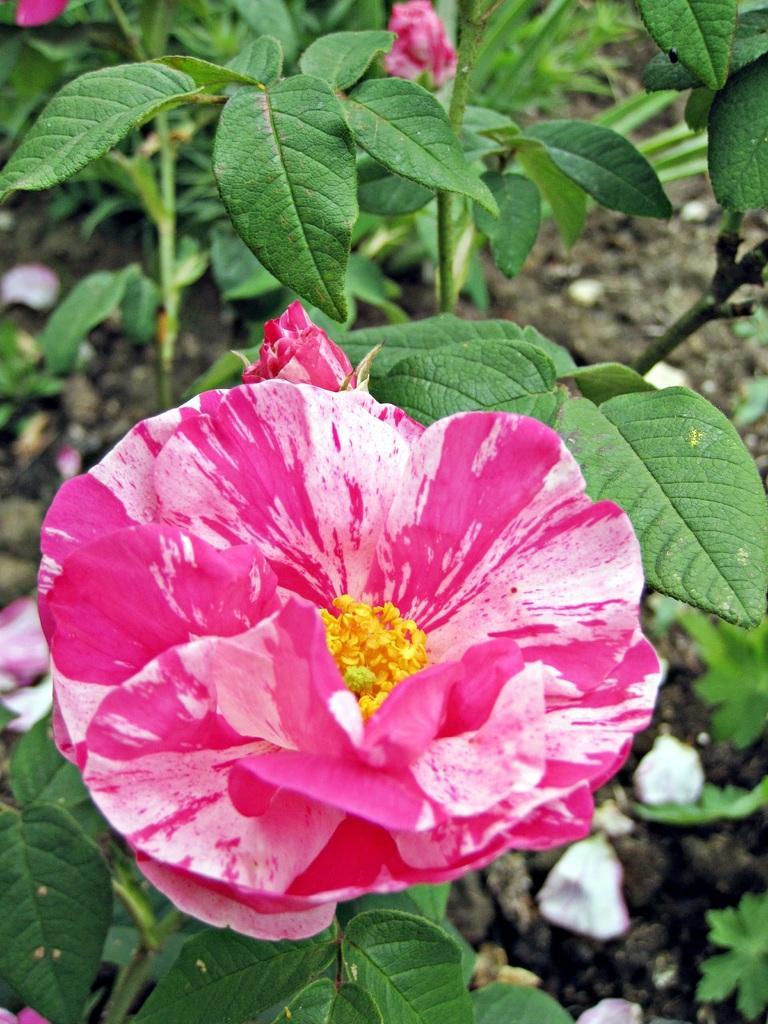Describe this image in one or two sentences. In this picture we can see a plant with a flower and buds. There are flower petals on the soil. 